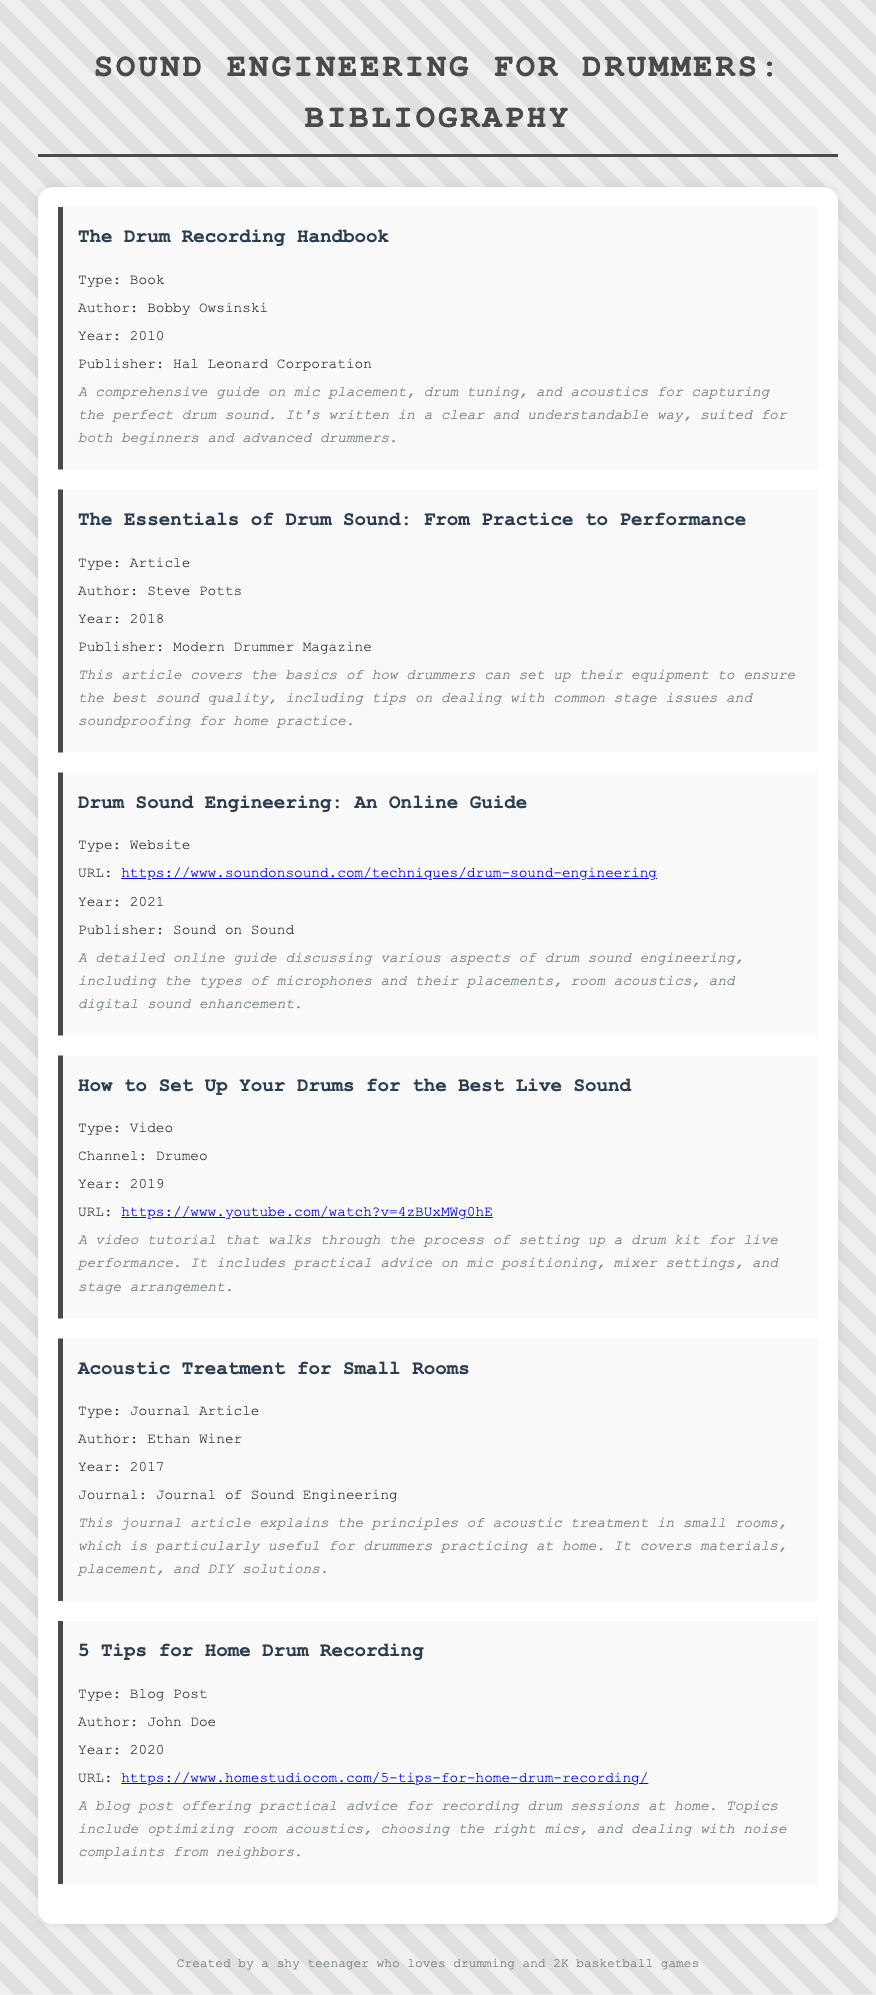What is the title of the first entry? The title is the first part of the first entry in the bibliography.
Answer: The Drum Recording Handbook Who authored "The Essentials of Drum Sound: From Practice to Performance"? The author is clearly indicated in the entry details of the document.
Answer: Steve Potts In what year was "Drum Sound Engineering: An Online Guide" published? The year is mentioned in the entry and refers to the publication date of the online resource.
Answer: 2021 What type of document is "5 Tips for Home Drum Recording"? The type of document is specified in the entry, identifying its format.
Answer: Blog Post Which publisher released "The Drum Recording Handbook"? The publisher is provided in the entry details of the referenced book.
Answer: Hal Leonard Corporation What is the focus of the article by Ethan Winer? The focus is derived from the title and details provided in the entry about the article.
Answer: Acoustic treatment for small rooms What medium is "How to Set Up Your Drums for the Best Live Sound"? The medium refers to the form in which the content is presented as stated in the entry.
Answer: Video Which guide covers mic placement and digital sound enhancement? The guide is identified by its title and content focus in the document.
Answer: Drum Sound Engineering: An Online Guide 